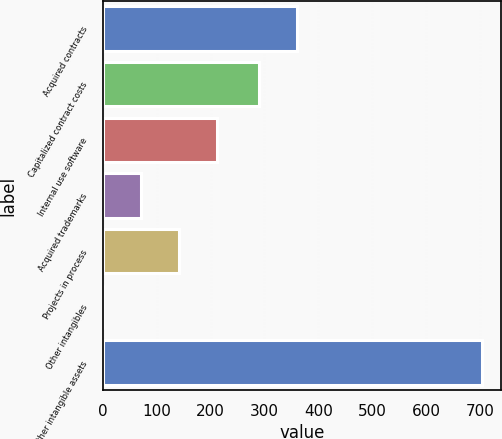Convert chart. <chart><loc_0><loc_0><loc_500><loc_500><bar_chart><fcel>Acquired contracts<fcel>Capitalized contract costs<fcel>Internal use software<fcel>Acquired trademarks<fcel>Projects in process<fcel>Other intangibles<fcel>Total other intangible assets<nl><fcel>360.85<fcel>290.4<fcel>211.85<fcel>70.95<fcel>141.4<fcel>0.5<fcel>705<nl></chart> 